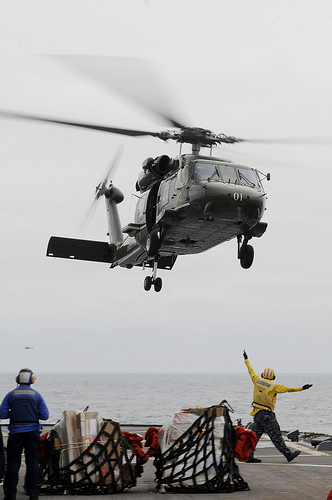<image>
Is the man under the helicopter? Yes. The man is positioned underneath the helicopter, with the helicopter above it in the vertical space. 